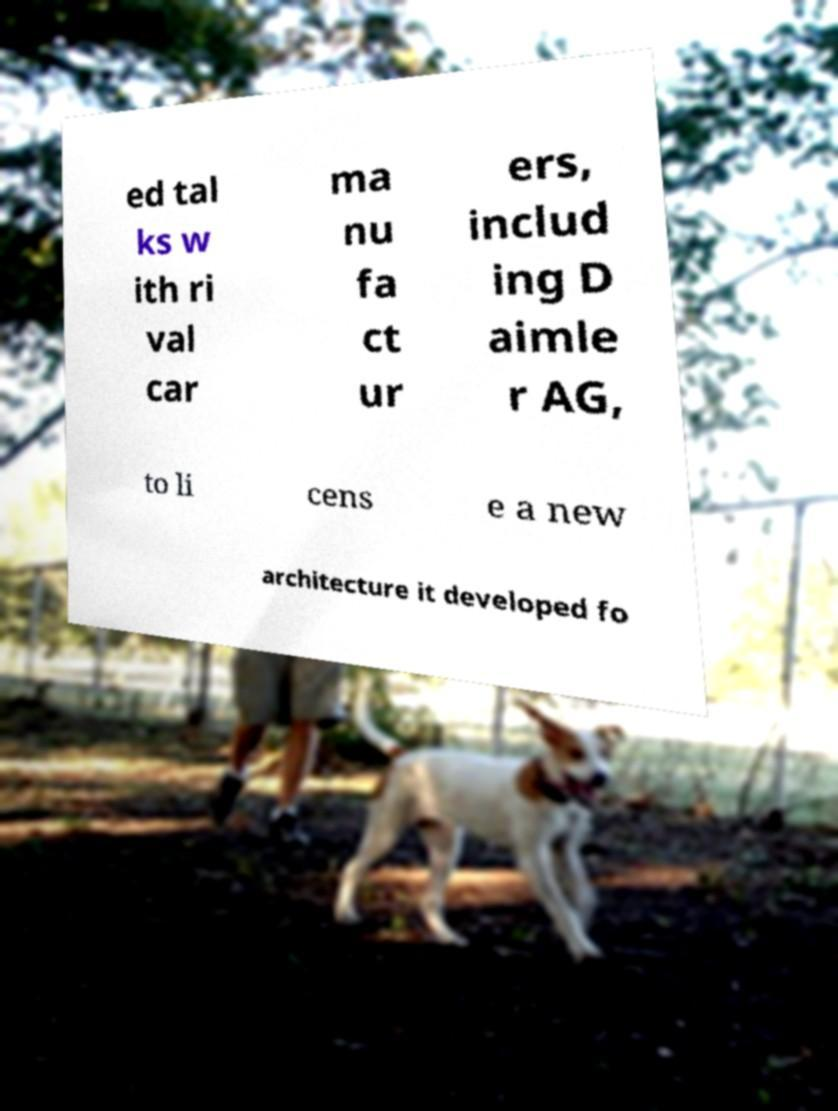Could you assist in decoding the text presented in this image and type it out clearly? ed tal ks w ith ri val car ma nu fa ct ur ers, includ ing D aimle r AG, to li cens e a new architecture it developed fo 